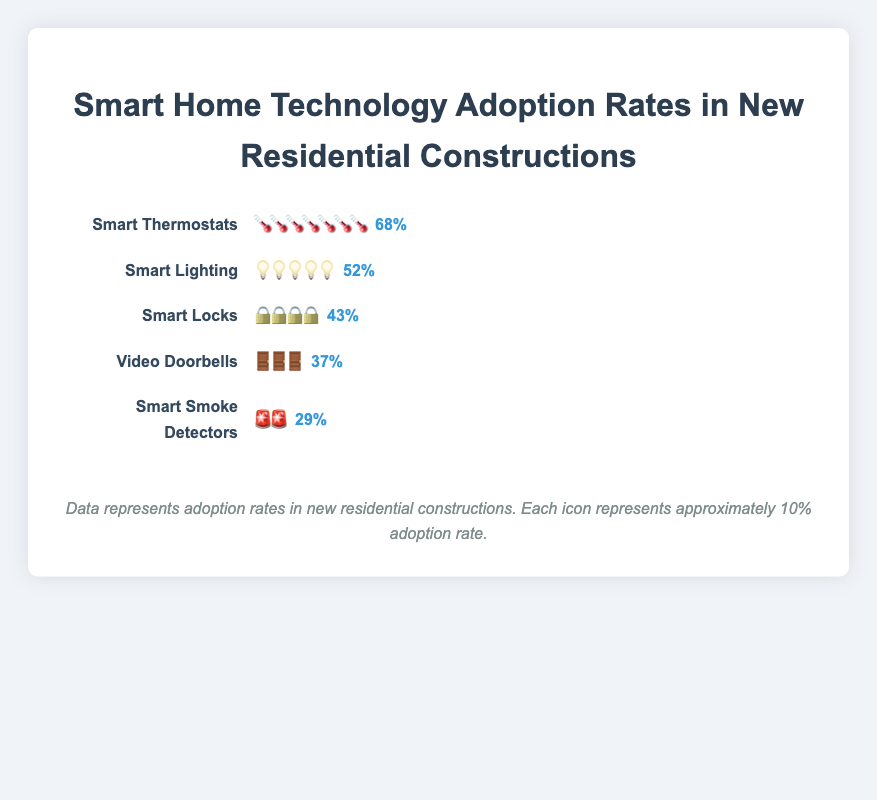What is the adoption rate of Smart Thermostats in new residential constructions? The percentage shown next to the icons for Smart Thermostats is 68%.
Answer: 68% Which device category has the lowest adoption rate? The category with the fewest icons is Smart Smoke Detectors, with a 29% adoption rate.
Answer: Smart Smoke Detectors How many percentage points higher is the adoption rate for Smart Thermostats compared to Video Doorbells? Smart Thermostats have a 68% adoption rate, and Video Doorbells have a 37% rate. The difference is 68% - 37% = 31 percentage points.
Answer: 31 percentage points What is the average adoption rate of Smart Locks and Smart Lighting? Smart Locks have a 43% rate and Smart Lighting has a 52% rate. The average is (43% + 52%) / 2 = 47.5%
Answer: 47.5% Are Smart Locks adopted more frequently than Video Doorbells in new residential constructions? The percentage for Smart Locks is 43%, whereas Video Doorbells have a 37% adoption rate. Thus, Smart Locks are adopted more frequently than Video Doorbells.
Answer: Yes Which technology has an adoption rate closest to 50%? Smart Lighting has an adoption rate of 52%, which is the closest to 50%.
Answer: Smart Lighting What is the total adoption rate of Smart Locks and Smart Smoke Detectors combined? Smart Locks have a 43% rate and Smart Smoke Detectors have a 29% rate. The total is 43% + 29% = 72%.
Answer: 72% How many devices have an adoption rate higher than 40%? The devices with adoption rates higher than 40% are Smart Thermostats (68%), Smart Lighting (52%), and Smart Locks (43%). That makes 3 devices in total.
Answer: 3 Which technology has an adoption rate of less than 40%? Video Doorbells have a 37% adoption rate, and Smart Smoke Detectors have a 29% adoption rate. Both are less than 40%.
Answer: Video Doorbells and Smart Smoke Detectors What is the gap in adoption rates between the most and least adopted technologies? The most adopted technology is Smart Thermostats at 68%, and the least adopted is Smart Smoke Detectors at 29%. The gap is 68% - 29% = 39%.
Answer: 39% 